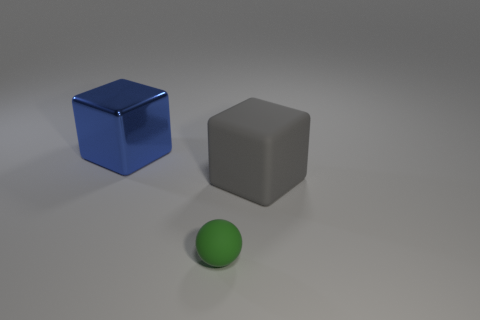Is there any shadow interaction between the objects? Yes, each object casts a shadow on the surface it rests upon, but there are no overlapping shadows that would suggest direct interaction between the objects. 